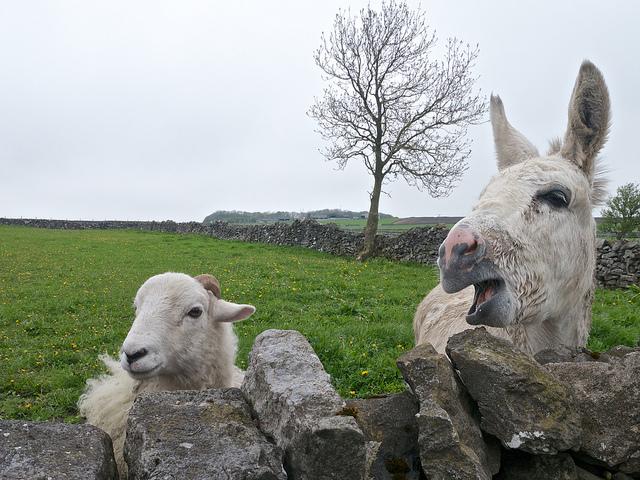What kind of animals are these?
Write a very short answer. Goat and donkey. How many animals are in the picture?
Write a very short answer. 2. How many trees are there?
Quick response, please. 2. 